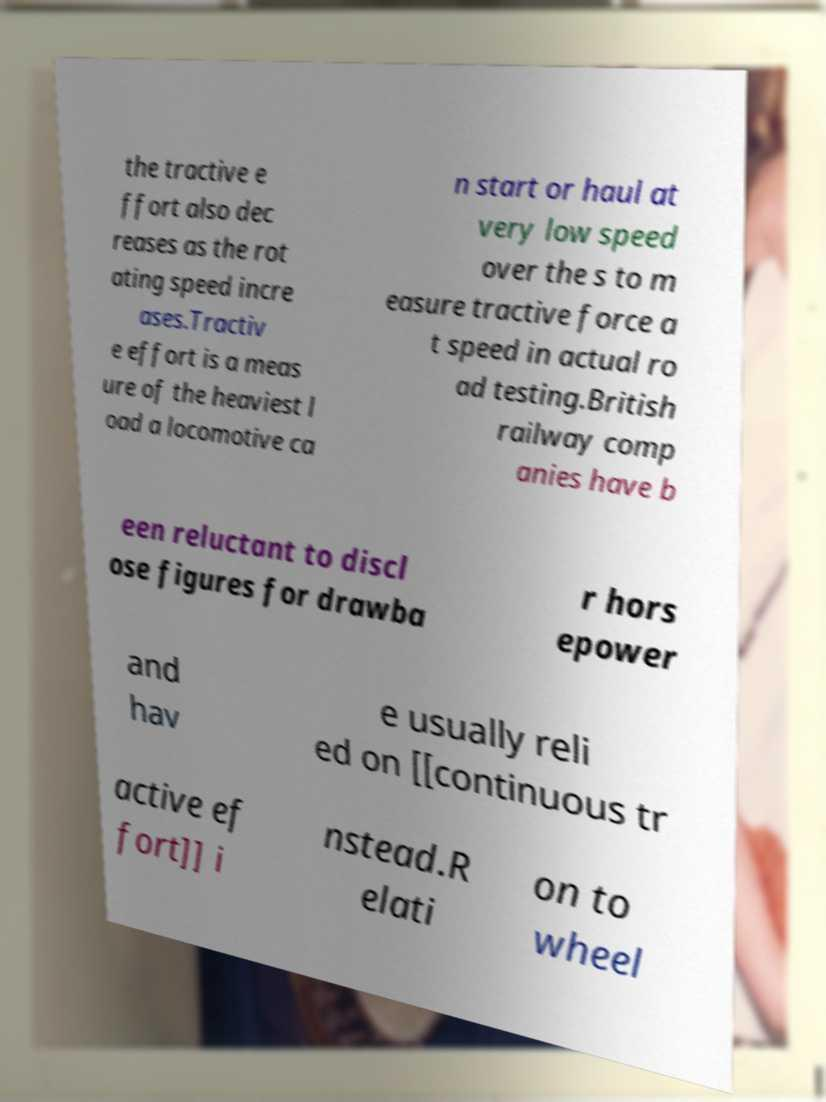Please identify and transcribe the text found in this image. the tractive e ffort also dec reases as the rot ating speed incre ases.Tractiv e effort is a meas ure of the heaviest l oad a locomotive ca n start or haul at very low speed over the s to m easure tractive force a t speed in actual ro ad testing.British railway comp anies have b een reluctant to discl ose figures for drawba r hors epower and hav e usually reli ed on [[continuous tr active ef fort]] i nstead.R elati on to wheel 